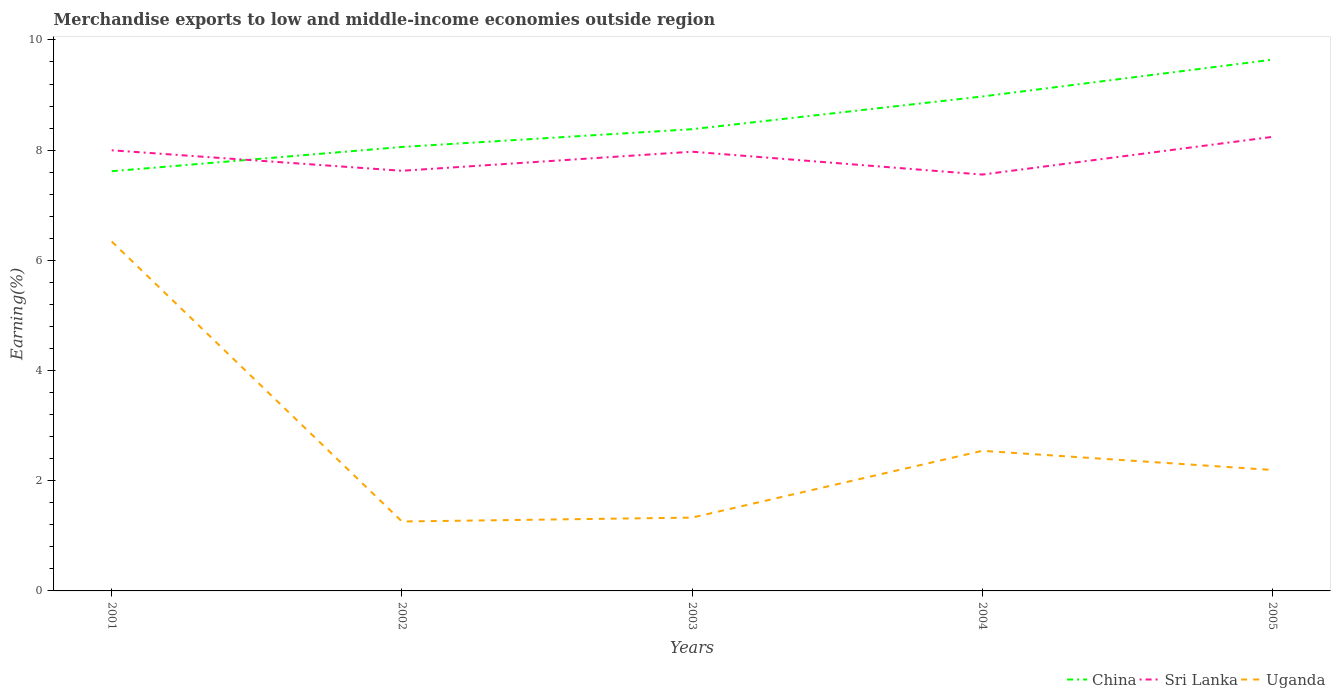Does the line corresponding to Uganda intersect with the line corresponding to Sri Lanka?
Provide a succinct answer. No. Across all years, what is the maximum percentage of amount earned from merchandise exports in China?
Offer a terse response. 7.62. What is the total percentage of amount earned from merchandise exports in China in the graph?
Your answer should be compact. -0.59. What is the difference between the highest and the second highest percentage of amount earned from merchandise exports in Sri Lanka?
Offer a very short reply. 0.68. What is the difference between the highest and the lowest percentage of amount earned from merchandise exports in China?
Provide a short and direct response. 2. Does the graph contain any zero values?
Provide a short and direct response. No. Does the graph contain grids?
Provide a short and direct response. No. How many legend labels are there?
Your answer should be compact. 3. How are the legend labels stacked?
Ensure brevity in your answer.  Horizontal. What is the title of the graph?
Give a very brief answer. Merchandise exports to low and middle-income economies outside region. What is the label or title of the Y-axis?
Your answer should be compact. Earning(%). What is the Earning(%) in China in 2001?
Your answer should be compact. 7.62. What is the Earning(%) in Sri Lanka in 2001?
Give a very brief answer. 8. What is the Earning(%) in Uganda in 2001?
Offer a terse response. 6.34. What is the Earning(%) of China in 2002?
Offer a terse response. 8.06. What is the Earning(%) in Sri Lanka in 2002?
Your answer should be very brief. 7.63. What is the Earning(%) in Uganda in 2002?
Ensure brevity in your answer.  1.26. What is the Earning(%) in China in 2003?
Keep it short and to the point. 8.38. What is the Earning(%) of Sri Lanka in 2003?
Your response must be concise. 7.97. What is the Earning(%) of Uganda in 2003?
Make the answer very short. 1.33. What is the Earning(%) of China in 2004?
Give a very brief answer. 8.97. What is the Earning(%) in Sri Lanka in 2004?
Provide a short and direct response. 7.56. What is the Earning(%) of Uganda in 2004?
Keep it short and to the point. 2.54. What is the Earning(%) in China in 2005?
Make the answer very short. 9.64. What is the Earning(%) of Sri Lanka in 2005?
Your answer should be very brief. 8.24. What is the Earning(%) in Uganda in 2005?
Your response must be concise. 2.2. Across all years, what is the maximum Earning(%) in China?
Your answer should be very brief. 9.64. Across all years, what is the maximum Earning(%) in Sri Lanka?
Keep it short and to the point. 8.24. Across all years, what is the maximum Earning(%) in Uganda?
Ensure brevity in your answer.  6.34. Across all years, what is the minimum Earning(%) in China?
Your response must be concise. 7.62. Across all years, what is the minimum Earning(%) of Sri Lanka?
Your response must be concise. 7.56. Across all years, what is the minimum Earning(%) of Uganda?
Your answer should be compact. 1.26. What is the total Earning(%) of China in the graph?
Your answer should be very brief. 42.67. What is the total Earning(%) in Sri Lanka in the graph?
Give a very brief answer. 39.39. What is the total Earning(%) of Uganda in the graph?
Offer a very short reply. 13.67. What is the difference between the Earning(%) of China in 2001 and that in 2002?
Make the answer very short. -0.44. What is the difference between the Earning(%) in Sri Lanka in 2001 and that in 2002?
Offer a terse response. 0.37. What is the difference between the Earning(%) of Uganda in 2001 and that in 2002?
Offer a terse response. 5.08. What is the difference between the Earning(%) in China in 2001 and that in 2003?
Provide a succinct answer. -0.76. What is the difference between the Earning(%) of Sri Lanka in 2001 and that in 2003?
Offer a terse response. 0.03. What is the difference between the Earning(%) in Uganda in 2001 and that in 2003?
Ensure brevity in your answer.  5.01. What is the difference between the Earning(%) in China in 2001 and that in 2004?
Keep it short and to the point. -1.36. What is the difference between the Earning(%) of Sri Lanka in 2001 and that in 2004?
Offer a terse response. 0.44. What is the difference between the Earning(%) of Uganda in 2001 and that in 2004?
Your answer should be compact. 3.8. What is the difference between the Earning(%) of China in 2001 and that in 2005?
Keep it short and to the point. -2.02. What is the difference between the Earning(%) in Sri Lanka in 2001 and that in 2005?
Provide a short and direct response. -0.24. What is the difference between the Earning(%) of Uganda in 2001 and that in 2005?
Make the answer very short. 4.15. What is the difference between the Earning(%) in China in 2002 and that in 2003?
Make the answer very short. -0.32. What is the difference between the Earning(%) of Sri Lanka in 2002 and that in 2003?
Keep it short and to the point. -0.35. What is the difference between the Earning(%) of Uganda in 2002 and that in 2003?
Make the answer very short. -0.07. What is the difference between the Earning(%) in China in 2002 and that in 2004?
Ensure brevity in your answer.  -0.92. What is the difference between the Earning(%) in Sri Lanka in 2002 and that in 2004?
Your response must be concise. 0.07. What is the difference between the Earning(%) in Uganda in 2002 and that in 2004?
Make the answer very short. -1.28. What is the difference between the Earning(%) of China in 2002 and that in 2005?
Provide a succinct answer. -1.58. What is the difference between the Earning(%) of Sri Lanka in 2002 and that in 2005?
Provide a short and direct response. -0.62. What is the difference between the Earning(%) in Uganda in 2002 and that in 2005?
Your answer should be very brief. -0.94. What is the difference between the Earning(%) of China in 2003 and that in 2004?
Your response must be concise. -0.59. What is the difference between the Earning(%) in Sri Lanka in 2003 and that in 2004?
Your answer should be compact. 0.41. What is the difference between the Earning(%) in Uganda in 2003 and that in 2004?
Provide a short and direct response. -1.21. What is the difference between the Earning(%) of China in 2003 and that in 2005?
Ensure brevity in your answer.  -1.26. What is the difference between the Earning(%) of Sri Lanka in 2003 and that in 2005?
Ensure brevity in your answer.  -0.27. What is the difference between the Earning(%) of Uganda in 2003 and that in 2005?
Offer a very short reply. -0.86. What is the difference between the Earning(%) in China in 2004 and that in 2005?
Give a very brief answer. -0.67. What is the difference between the Earning(%) in Sri Lanka in 2004 and that in 2005?
Make the answer very short. -0.68. What is the difference between the Earning(%) of Uganda in 2004 and that in 2005?
Ensure brevity in your answer.  0.35. What is the difference between the Earning(%) in China in 2001 and the Earning(%) in Sri Lanka in 2002?
Keep it short and to the point. -0.01. What is the difference between the Earning(%) of China in 2001 and the Earning(%) of Uganda in 2002?
Make the answer very short. 6.36. What is the difference between the Earning(%) in Sri Lanka in 2001 and the Earning(%) in Uganda in 2002?
Give a very brief answer. 6.74. What is the difference between the Earning(%) of China in 2001 and the Earning(%) of Sri Lanka in 2003?
Provide a short and direct response. -0.35. What is the difference between the Earning(%) in China in 2001 and the Earning(%) in Uganda in 2003?
Ensure brevity in your answer.  6.29. What is the difference between the Earning(%) in Sri Lanka in 2001 and the Earning(%) in Uganda in 2003?
Offer a terse response. 6.67. What is the difference between the Earning(%) in China in 2001 and the Earning(%) in Sri Lanka in 2004?
Your answer should be very brief. 0.06. What is the difference between the Earning(%) of China in 2001 and the Earning(%) of Uganda in 2004?
Keep it short and to the point. 5.07. What is the difference between the Earning(%) in Sri Lanka in 2001 and the Earning(%) in Uganda in 2004?
Your answer should be very brief. 5.45. What is the difference between the Earning(%) of China in 2001 and the Earning(%) of Sri Lanka in 2005?
Ensure brevity in your answer.  -0.62. What is the difference between the Earning(%) of China in 2001 and the Earning(%) of Uganda in 2005?
Provide a short and direct response. 5.42. What is the difference between the Earning(%) in Sri Lanka in 2001 and the Earning(%) in Uganda in 2005?
Provide a short and direct response. 5.8. What is the difference between the Earning(%) of China in 2002 and the Earning(%) of Sri Lanka in 2003?
Your answer should be compact. 0.09. What is the difference between the Earning(%) in China in 2002 and the Earning(%) in Uganda in 2003?
Provide a succinct answer. 6.73. What is the difference between the Earning(%) in Sri Lanka in 2002 and the Earning(%) in Uganda in 2003?
Provide a succinct answer. 6.29. What is the difference between the Earning(%) of China in 2002 and the Earning(%) of Sri Lanka in 2004?
Provide a succinct answer. 0.5. What is the difference between the Earning(%) in China in 2002 and the Earning(%) in Uganda in 2004?
Offer a terse response. 5.51. What is the difference between the Earning(%) in Sri Lanka in 2002 and the Earning(%) in Uganda in 2004?
Your answer should be very brief. 5.08. What is the difference between the Earning(%) of China in 2002 and the Earning(%) of Sri Lanka in 2005?
Give a very brief answer. -0.18. What is the difference between the Earning(%) of China in 2002 and the Earning(%) of Uganda in 2005?
Make the answer very short. 5.86. What is the difference between the Earning(%) in Sri Lanka in 2002 and the Earning(%) in Uganda in 2005?
Give a very brief answer. 5.43. What is the difference between the Earning(%) of China in 2003 and the Earning(%) of Sri Lanka in 2004?
Your answer should be compact. 0.82. What is the difference between the Earning(%) in China in 2003 and the Earning(%) in Uganda in 2004?
Provide a short and direct response. 5.84. What is the difference between the Earning(%) of Sri Lanka in 2003 and the Earning(%) of Uganda in 2004?
Your answer should be compact. 5.43. What is the difference between the Earning(%) in China in 2003 and the Earning(%) in Sri Lanka in 2005?
Your answer should be very brief. 0.14. What is the difference between the Earning(%) of China in 2003 and the Earning(%) of Uganda in 2005?
Your answer should be compact. 6.18. What is the difference between the Earning(%) in Sri Lanka in 2003 and the Earning(%) in Uganda in 2005?
Offer a very short reply. 5.78. What is the difference between the Earning(%) of China in 2004 and the Earning(%) of Sri Lanka in 2005?
Your response must be concise. 0.73. What is the difference between the Earning(%) of China in 2004 and the Earning(%) of Uganda in 2005?
Give a very brief answer. 6.78. What is the difference between the Earning(%) in Sri Lanka in 2004 and the Earning(%) in Uganda in 2005?
Your answer should be very brief. 5.36. What is the average Earning(%) of China per year?
Your response must be concise. 8.53. What is the average Earning(%) of Sri Lanka per year?
Ensure brevity in your answer.  7.88. What is the average Earning(%) in Uganda per year?
Your response must be concise. 2.73. In the year 2001, what is the difference between the Earning(%) of China and Earning(%) of Sri Lanka?
Provide a succinct answer. -0.38. In the year 2001, what is the difference between the Earning(%) in China and Earning(%) in Uganda?
Provide a short and direct response. 1.28. In the year 2001, what is the difference between the Earning(%) of Sri Lanka and Earning(%) of Uganda?
Make the answer very short. 1.66. In the year 2002, what is the difference between the Earning(%) in China and Earning(%) in Sri Lanka?
Make the answer very short. 0.43. In the year 2002, what is the difference between the Earning(%) of China and Earning(%) of Uganda?
Make the answer very short. 6.8. In the year 2002, what is the difference between the Earning(%) of Sri Lanka and Earning(%) of Uganda?
Your answer should be compact. 6.37. In the year 2003, what is the difference between the Earning(%) in China and Earning(%) in Sri Lanka?
Ensure brevity in your answer.  0.41. In the year 2003, what is the difference between the Earning(%) of China and Earning(%) of Uganda?
Your answer should be very brief. 7.05. In the year 2003, what is the difference between the Earning(%) in Sri Lanka and Earning(%) in Uganda?
Your answer should be compact. 6.64. In the year 2004, what is the difference between the Earning(%) of China and Earning(%) of Sri Lanka?
Provide a short and direct response. 1.42. In the year 2004, what is the difference between the Earning(%) in China and Earning(%) in Uganda?
Your answer should be very brief. 6.43. In the year 2004, what is the difference between the Earning(%) in Sri Lanka and Earning(%) in Uganda?
Give a very brief answer. 5.01. In the year 2005, what is the difference between the Earning(%) in China and Earning(%) in Sri Lanka?
Provide a short and direct response. 1.4. In the year 2005, what is the difference between the Earning(%) in China and Earning(%) in Uganda?
Provide a succinct answer. 7.45. In the year 2005, what is the difference between the Earning(%) of Sri Lanka and Earning(%) of Uganda?
Your answer should be very brief. 6.05. What is the ratio of the Earning(%) in China in 2001 to that in 2002?
Provide a short and direct response. 0.95. What is the ratio of the Earning(%) in Sri Lanka in 2001 to that in 2002?
Provide a short and direct response. 1.05. What is the ratio of the Earning(%) of Uganda in 2001 to that in 2002?
Make the answer very short. 5.03. What is the ratio of the Earning(%) of China in 2001 to that in 2003?
Give a very brief answer. 0.91. What is the ratio of the Earning(%) of Sri Lanka in 2001 to that in 2003?
Your response must be concise. 1. What is the ratio of the Earning(%) of Uganda in 2001 to that in 2003?
Your answer should be very brief. 4.77. What is the ratio of the Earning(%) of China in 2001 to that in 2004?
Provide a succinct answer. 0.85. What is the ratio of the Earning(%) in Sri Lanka in 2001 to that in 2004?
Keep it short and to the point. 1.06. What is the ratio of the Earning(%) in Uganda in 2001 to that in 2004?
Your answer should be compact. 2.49. What is the ratio of the Earning(%) of China in 2001 to that in 2005?
Provide a short and direct response. 0.79. What is the ratio of the Earning(%) in Sri Lanka in 2001 to that in 2005?
Offer a very short reply. 0.97. What is the ratio of the Earning(%) in Uganda in 2001 to that in 2005?
Your answer should be very brief. 2.89. What is the ratio of the Earning(%) of China in 2002 to that in 2003?
Ensure brevity in your answer.  0.96. What is the ratio of the Earning(%) of Sri Lanka in 2002 to that in 2003?
Your answer should be compact. 0.96. What is the ratio of the Earning(%) of Uganda in 2002 to that in 2003?
Make the answer very short. 0.95. What is the ratio of the Earning(%) of China in 2002 to that in 2004?
Your answer should be very brief. 0.9. What is the ratio of the Earning(%) in Sri Lanka in 2002 to that in 2004?
Offer a terse response. 1.01. What is the ratio of the Earning(%) in Uganda in 2002 to that in 2004?
Provide a short and direct response. 0.5. What is the ratio of the Earning(%) in China in 2002 to that in 2005?
Give a very brief answer. 0.84. What is the ratio of the Earning(%) in Sri Lanka in 2002 to that in 2005?
Provide a succinct answer. 0.93. What is the ratio of the Earning(%) in Uganda in 2002 to that in 2005?
Give a very brief answer. 0.57. What is the ratio of the Earning(%) in China in 2003 to that in 2004?
Your response must be concise. 0.93. What is the ratio of the Earning(%) in Sri Lanka in 2003 to that in 2004?
Keep it short and to the point. 1.05. What is the ratio of the Earning(%) of Uganda in 2003 to that in 2004?
Your answer should be very brief. 0.52. What is the ratio of the Earning(%) in China in 2003 to that in 2005?
Provide a short and direct response. 0.87. What is the ratio of the Earning(%) of Sri Lanka in 2003 to that in 2005?
Offer a very short reply. 0.97. What is the ratio of the Earning(%) in Uganda in 2003 to that in 2005?
Provide a succinct answer. 0.61. What is the ratio of the Earning(%) of China in 2004 to that in 2005?
Provide a short and direct response. 0.93. What is the ratio of the Earning(%) of Sri Lanka in 2004 to that in 2005?
Provide a succinct answer. 0.92. What is the ratio of the Earning(%) of Uganda in 2004 to that in 2005?
Keep it short and to the point. 1.16. What is the difference between the highest and the second highest Earning(%) of China?
Provide a short and direct response. 0.67. What is the difference between the highest and the second highest Earning(%) in Sri Lanka?
Give a very brief answer. 0.24. What is the difference between the highest and the second highest Earning(%) of Uganda?
Offer a very short reply. 3.8. What is the difference between the highest and the lowest Earning(%) in China?
Give a very brief answer. 2.02. What is the difference between the highest and the lowest Earning(%) in Sri Lanka?
Your answer should be compact. 0.68. What is the difference between the highest and the lowest Earning(%) of Uganda?
Offer a very short reply. 5.08. 